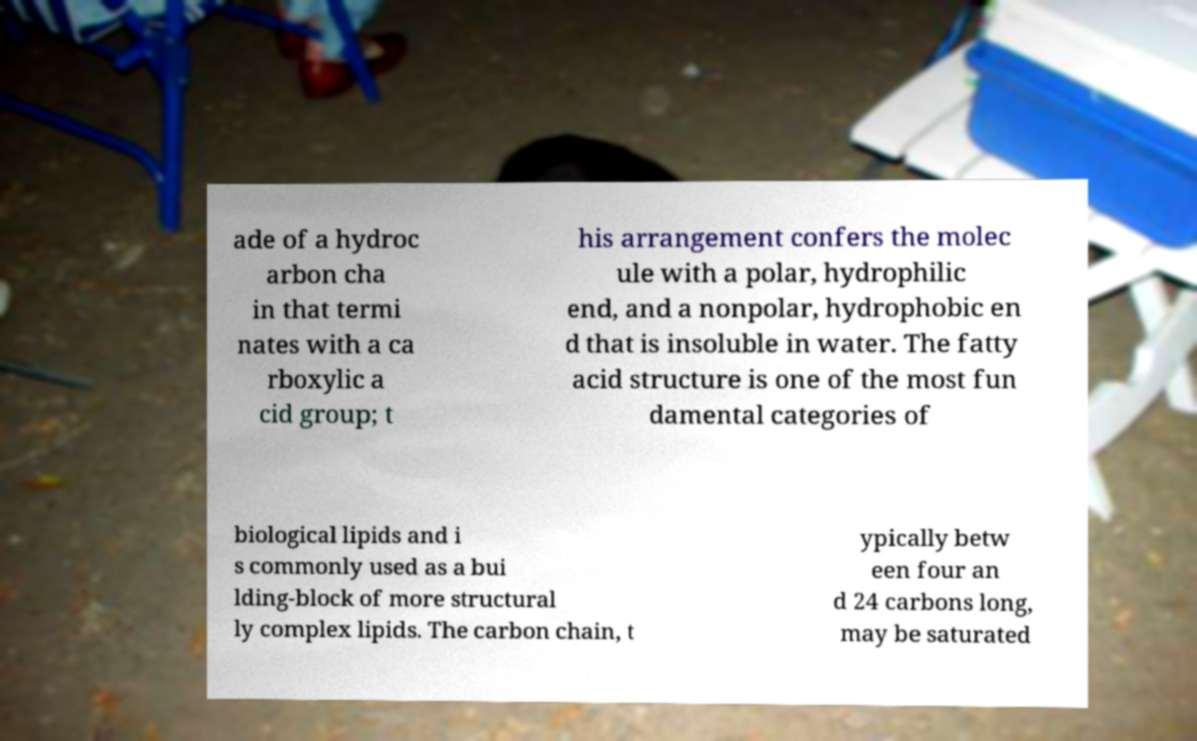What messages or text are displayed in this image? I need them in a readable, typed format. ade of a hydroc arbon cha in that termi nates with a ca rboxylic a cid group; t his arrangement confers the molec ule with a polar, hydrophilic end, and a nonpolar, hydrophobic en d that is insoluble in water. The fatty acid structure is one of the most fun damental categories of biological lipids and i s commonly used as a bui lding-block of more structural ly complex lipids. The carbon chain, t ypically betw een four an d 24 carbons long, may be saturated 